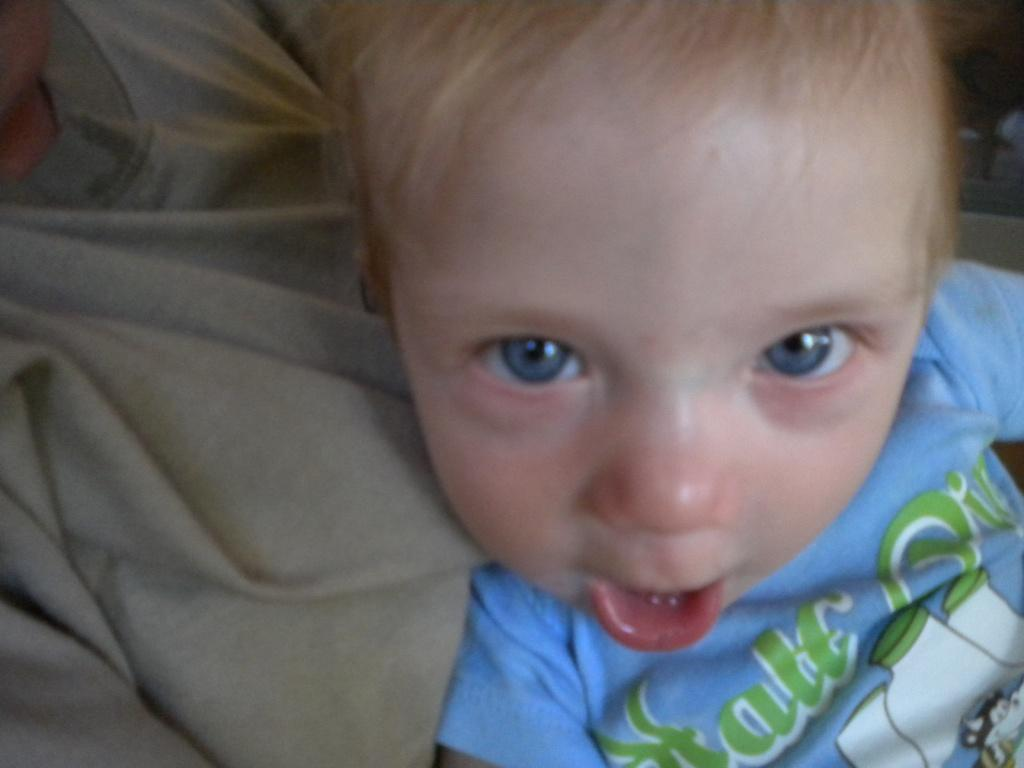How many people are in the image? There are two persons in the image. What is the appearance of one of the persons? One of the persons is wearing a blue shirt. Can you describe the other person in the image? The other person is partially visible or truncated. What type of winter clothing is the person with the blue shirt wearing? There is no mention of winter clothing in the image, as it does not depict a winter scene or any specific clothing items. 